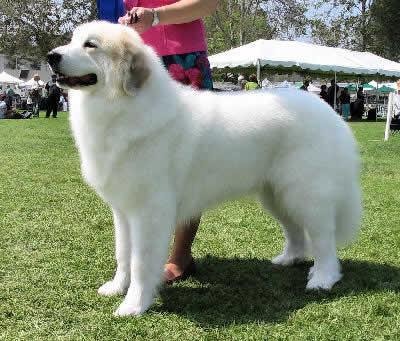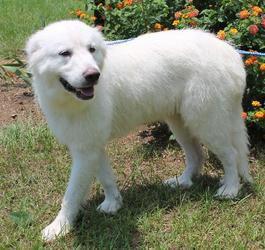The first image is the image on the left, the second image is the image on the right. Given the left and right images, does the statement "The dog in the image on the right is lying in the grass outside." hold true? Answer yes or no. No. The first image is the image on the left, the second image is the image on the right. Given the left and right images, does the statement "Each image shows one dog which is standing on all fours." hold true? Answer yes or no. Yes. 